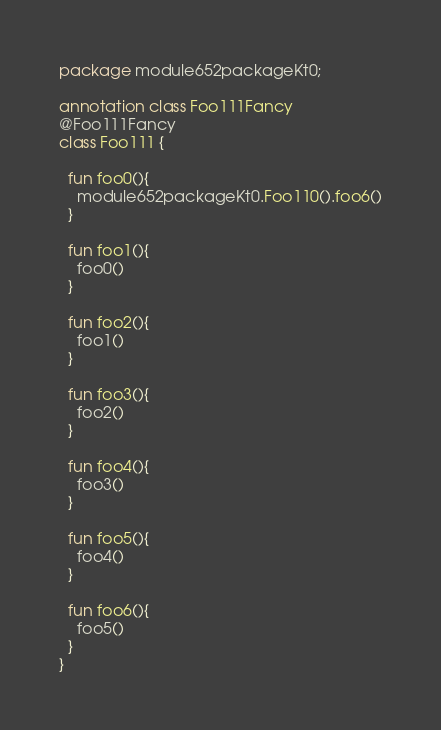Convert code to text. <code><loc_0><loc_0><loc_500><loc_500><_Kotlin_>package module652packageKt0;

annotation class Foo111Fancy
@Foo111Fancy
class Foo111 {

  fun foo0(){
    module652packageKt0.Foo110().foo6()
  }

  fun foo1(){
    foo0()
  }

  fun foo2(){
    foo1()
  }

  fun foo3(){
    foo2()
  }

  fun foo4(){
    foo3()
  }

  fun foo5(){
    foo4()
  }

  fun foo6(){
    foo5()
  }
}</code> 